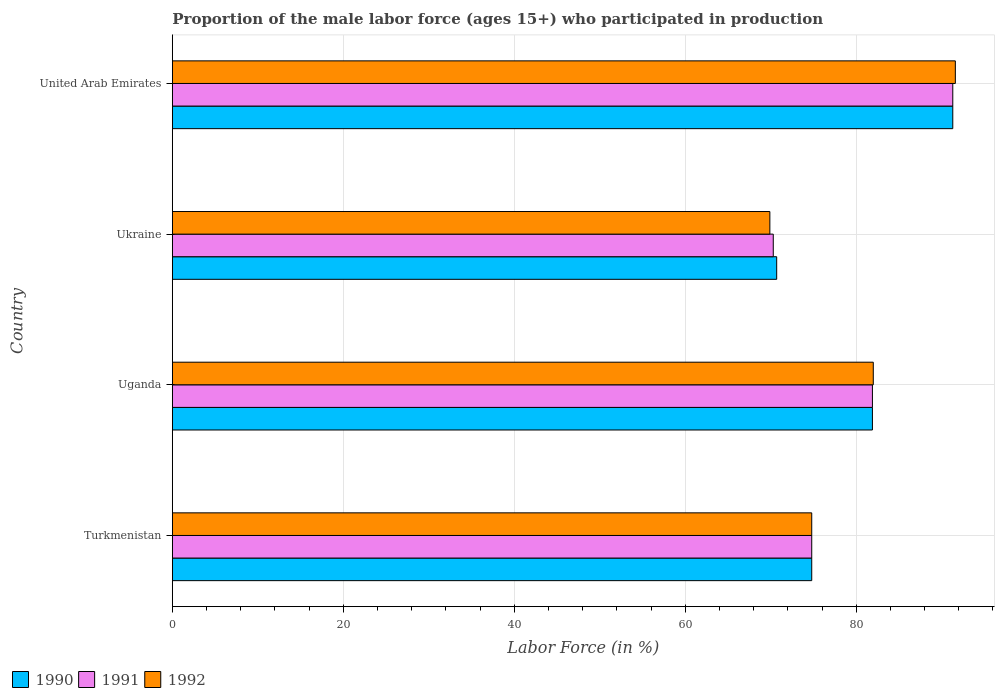How many different coloured bars are there?
Ensure brevity in your answer.  3. Are the number of bars on each tick of the Y-axis equal?
Provide a succinct answer. Yes. How many bars are there on the 1st tick from the bottom?
Make the answer very short. 3. What is the label of the 1st group of bars from the top?
Ensure brevity in your answer.  United Arab Emirates. In how many cases, is the number of bars for a given country not equal to the number of legend labels?
Offer a terse response. 0. What is the proportion of the male labor force who participated in production in 1990 in Turkmenistan?
Keep it short and to the point. 74.8. Across all countries, what is the maximum proportion of the male labor force who participated in production in 1991?
Offer a very short reply. 91.3. Across all countries, what is the minimum proportion of the male labor force who participated in production in 1992?
Your answer should be compact. 69.9. In which country was the proportion of the male labor force who participated in production in 1991 maximum?
Give a very brief answer. United Arab Emirates. In which country was the proportion of the male labor force who participated in production in 1991 minimum?
Your answer should be compact. Ukraine. What is the total proportion of the male labor force who participated in production in 1992 in the graph?
Provide a succinct answer. 318.3. What is the difference between the proportion of the male labor force who participated in production in 1991 in Ukraine and that in United Arab Emirates?
Offer a very short reply. -21. What is the difference between the proportion of the male labor force who participated in production in 1992 in Uganda and the proportion of the male labor force who participated in production in 1991 in Turkmenistan?
Provide a short and direct response. 7.2. What is the average proportion of the male labor force who participated in production in 1992 per country?
Keep it short and to the point. 79.58. What is the difference between the proportion of the male labor force who participated in production in 1992 and proportion of the male labor force who participated in production in 1991 in Uganda?
Ensure brevity in your answer.  0.1. In how many countries, is the proportion of the male labor force who participated in production in 1991 greater than 68 %?
Ensure brevity in your answer.  4. What is the ratio of the proportion of the male labor force who participated in production in 1990 in Uganda to that in Ukraine?
Offer a terse response. 1.16. Is the difference between the proportion of the male labor force who participated in production in 1992 in Uganda and Ukraine greater than the difference between the proportion of the male labor force who participated in production in 1991 in Uganda and Ukraine?
Your answer should be compact. Yes. What is the difference between the highest and the second highest proportion of the male labor force who participated in production in 1990?
Your answer should be compact. 9.4. In how many countries, is the proportion of the male labor force who participated in production in 1991 greater than the average proportion of the male labor force who participated in production in 1991 taken over all countries?
Offer a terse response. 2. What does the 2nd bar from the bottom in United Arab Emirates represents?
Make the answer very short. 1991. Are all the bars in the graph horizontal?
Give a very brief answer. Yes. How many countries are there in the graph?
Make the answer very short. 4. Are the values on the major ticks of X-axis written in scientific E-notation?
Provide a short and direct response. No. Where does the legend appear in the graph?
Your answer should be very brief. Bottom left. How are the legend labels stacked?
Your response must be concise. Horizontal. What is the title of the graph?
Your answer should be compact. Proportion of the male labor force (ages 15+) who participated in production. What is the label or title of the X-axis?
Offer a terse response. Labor Force (in %). What is the label or title of the Y-axis?
Provide a short and direct response. Country. What is the Labor Force (in %) in 1990 in Turkmenistan?
Offer a very short reply. 74.8. What is the Labor Force (in %) of 1991 in Turkmenistan?
Your answer should be very brief. 74.8. What is the Labor Force (in %) of 1992 in Turkmenistan?
Provide a succinct answer. 74.8. What is the Labor Force (in %) in 1990 in Uganda?
Offer a terse response. 81.9. What is the Labor Force (in %) in 1991 in Uganda?
Provide a succinct answer. 81.9. What is the Labor Force (in %) of 1992 in Uganda?
Your response must be concise. 82. What is the Labor Force (in %) in 1990 in Ukraine?
Give a very brief answer. 70.7. What is the Labor Force (in %) in 1991 in Ukraine?
Provide a succinct answer. 70.3. What is the Labor Force (in %) in 1992 in Ukraine?
Your answer should be compact. 69.9. What is the Labor Force (in %) in 1990 in United Arab Emirates?
Your answer should be compact. 91.3. What is the Labor Force (in %) of 1991 in United Arab Emirates?
Give a very brief answer. 91.3. What is the Labor Force (in %) in 1992 in United Arab Emirates?
Keep it short and to the point. 91.6. Across all countries, what is the maximum Labor Force (in %) of 1990?
Your answer should be very brief. 91.3. Across all countries, what is the maximum Labor Force (in %) of 1991?
Make the answer very short. 91.3. Across all countries, what is the maximum Labor Force (in %) in 1992?
Your answer should be very brief. 91.6. Across all countries, what is the minimum Labor Force (in %) in 1990?
Give a very brief answer. 70.7. Across all countries, what is the minimum Labor Force (in %) in 1991?
Offer a very short reply. 70.3. Across all countries, what is the minimum Labor Force (in %) in 1992?
Make the answer very short. 69.9. What is the total Labor Force (in %) in 1990 in the graph?
Offer a terse response. 318.7. What is the total Labor Force (in %) in 1991 in the graph?
Offer a terse response. 318.3. What is the total Labor Force (in %) of 1992 in the graph?
Your answer should be very brief. 318.3. What is the difference between the Labor Force (in %) of 1990 in Turkmenistan and that in Uganda?
Offer a terse response. -7.1. What is the difference between the Labor Force (in %) of 1992 in Turkmenistan and that in Uganda?
Your response must be concise. -7.2. What is the difference between the Labor Force (in %) of 1990 in Turkmenistan and that in United Arab Emirates?
Your answer should be compact. -16.5. What is the difference between the Labor Force (in %) of 1991 in Turkmenistan and that in United Arab Emirates?
Your answer should be compact. -16.5. What is the difference between the Labor Force (in %) in 1992 in Turkmenistan and that in United Arab Emirates?
Offer a terse response. -16.8. What is the difference between the Labor Force (in %) in 1990 in Uganda and that in Ukraine?
Keep it short and to the point. 11.2. What is the difference between the Labor Force (in %) in 1990 in Uganda and that in United Arab Emirates?
Offer a very short reply. -9.4. What is the difference between the Labor Force (in %) in 1991 in Uganda and that in United Arab Emirates?
Offer a terse response. -9.4. What is the difference between the Labor Force (in %) of 1990 in Ukraine and that in United Arab Emirates?
Your answer should be compact. -20.6. What is the difference between the Labor Force (in %) in 1992 in Ukraine and that in United Arab Emirates?
Provide a short and direct response. -21.7. What is the difference between the Labor Force (in %) in 1990 in Turkmenistan and the Labor Force (in %) in 1992 in Uganda?
Your answer should be very brief. -7.2. What is the difference between the Labor Force (in %) in 1991 in Turkmenistan and the Labor Force (in %) in 1992 in Uganda?
Ensure brevity in your answer.  -7.2. What is the difference between the Labor Force (in %) of 1990 in Turkmenistan and the Labor Force (in %) of 1991 in Ukraine?
Your response must be concise. 4.5. What is the difference between the Labor Force (in %) in 1991 in Turkmenistan and the Labor Force (in %) in 1992 in Ukraine?
Your answer should be very brief. 4.9. What is the difference between the Labor Force (in %) in 1990 in Turkmenistan and the Labor Force (in %) in 1991 in United Arab Emirates?
Offer a very short reply. -16.5. What is the difference between the Labor Force (in %) in 1990 in Turkmenistan and the Labor Force (in %) in 1992 in United Arab Emirates?
Make the answer very short. -16.8. What is the difference between the Labor Force (in %) of 1991 in Turkmenistan and the Labor Force (in %) of 1992 in United Arab Emirates?
Make the answer very short. -16.8. What is the difference between the Labor Force (in %) in 1990 in Uganda and the Labor Force (in %) in 1992 in United Arab Emirates?
Make the answer very short. -9.7. What is the difference between the Labor Force (in %) of 1990 in Ukraine and the Labor Force (in %) of 1991 in United Arab Emirates?
Your answer should be compact. -20.6. What is the difference between the Labor Force (in %) of 1990 in Ukraine and the Labor Force (in %) of 1992 in United Arab Emirates?
Your answer should be very brief. -20.9. What is the difference between the Labor Force (in %) of 1991 in Ukraine and the Labor Force (in %) of 1992 in United Arab Emirates?
Your response must be concise. -21.3. What is the average Labor Force (in %) in 1990 per country?
Give a very brief answer. 79.67. What is the average Labor Force (in %) of 1991 per country?
Make the answer very short. 79.58. What is the average Labor Force (in %) of 1992 per country?
Make the answer very short. 79.58. What is the difference between the Labor Force (in %) of 1990 and Labor Force (in %) of 1991 in Uganda?
Offer a very short reply. 0. What is the difference between the Labor Force (in %) in 1991 and Labor Force (in %) in 1992 in Uganda?
Offer a terse response. -0.1. What is the difference between the Labor Force (in %) in 1990 and Labor Force (in %) in 1991 in Ukraine?
Your answer should be very brief. 0.4. What is the difference between the Labor Force (in %) in 1990 and Labor Force (in %) in 1992 in Ukraine?
Offer a very short reply. 0.8. What is the difference between the Labor Force (in %) of 1991 and Labor Force (in %) of 1992 in Ukraine?
Ensure brevity in your answer.  0.4. What is the difference between the Labor Force (in %) in 1990 and Labor Force (in %) in 1991 in United Arab Emirates?
Offer a terse response. 0. What is the ratio of the Labor Force (in %) of 1990 in Turkmenistan to that in Uganda?
Ensure brevity in your answer.  0.91. What is the ratio of the Labor Force (in %) of 1991 in Turkmenistan to that in Uganda?
Keep it short and to the point. 0.91. What is the ratio of the Labor Force (in %) in 1992 in Turkmenistan to that in Uganda?
Offer a terse response. 0.91. What is the ratio of the Labor Force (in %) in 1990 in Turkmenistan to that in Ukraine?
Make the answer very short. 1.06. What is the ratio of the Labor Force (in %) of 1991 in Turkmenistan to that in Ukraine?
Offer a very short reply. 1.06. What is the ratio of the Labor Force (in %) in 1992 in Turkmenistan to that in Ukraine?
Your response must be concise. 1.07. What is the ratio of the Labor Force (in %) in 1990 in Turkmenistan to that in United Arab Emirates?
Offer a very short reply. 0.82. What is the ratio of the Labor Force (in %) in 1991 in Turkmenistan to that in United Arab Emirates?
Offer a terse response. 0.82. What is the ratio of the Labor Force (in %) of 1992 in Turkmenistan to that in United Arab Emirates?
Your answer should be compact. 0.82. What is the ratio of the Labor Force (in %) in 1990 in Uganda to that in Ukraine?
Provide a short and direct response. 1.16. What is the ratio of the Labor Force (in %) of 1991 in Uganda to that in Ukraine?
Your answer should be very brief. 1.17. What is the ratio of the Labor Force (in %) of 1992 in Uganda to that in Ukraine?
Give a very brief answer. 1.17. What is the ratio of the Labor Force (in %) of 1990 in Uganda to that in United Arab Emirates?
Your answer should be compact. 0.9. What is the ratio of the Labor Force (in %) in 1991 in Uganda to that in United Arab Emirates?
Provide a short and direct response. 0.9. What is the ratio of the Labor Force (in %) of 1992 in Uganda to that in United Arab Emirates?
Give a very brief answer. 0.9. What is the ratio of the Labor Force (in %) of 1990 in Ukraine to that in United Arab Emirates?
Give a very brief answer. 0.77. What is the ratio of the Labor Force (in %) of 1991 in Ukraine to that in United Arab Emirates?
Your answer should be compact. 0.77. What is the ratio of the Labor Force (in %) of 1992 in Ukraine to that in United Arab Emirates?
Make the answer very short. 0.76. What is the difference between the highest and the second highest Labor Force (in %) of 1990?
Offer a terse response. 9.4. What is the difference between the highest and the second highest Labor Force (in %) in 1992?
Provide a short and direct response. 9.6. What is the difference between the highest and the lowest Labor Force (in %) in 1990?
Make the answer very short. 20.6. What is the difference between the highest and the lowest Labor Force (in %) of 1992?
Your response must be concise. 21.7. 